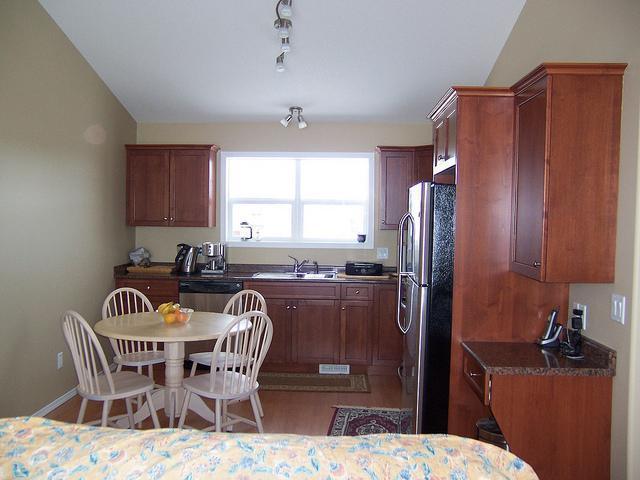How many windows are there?
Give a very brief answer. 1. How many chairs are at the table?
Give a very brief answer. 4. How many refrigerators are in the picture?
Give a very brief answer. 1. How many chairs are in the picture?
Give a very brief answer. 3. How many motorcycles are in the pic?
Give a very brief answer. 0. 